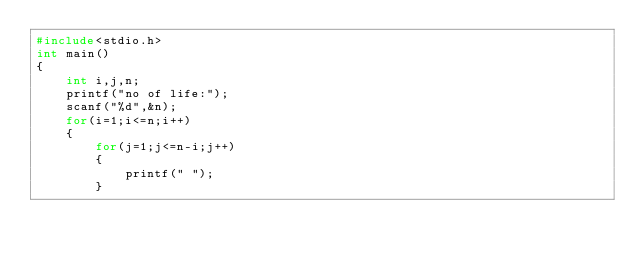Convert code to text. <code><loc_0><loc_0><loc_500><loc_500><_C_>#include<stdio.h>
int main()
{
	int i,j,n;
	printf("no of life:");
	scanf("%d",&n);
	for(i=1;i<=n;i++)
	{
		for(j=1;j<=n-i;j++)
		{
			printf(" ");
		}</code> 